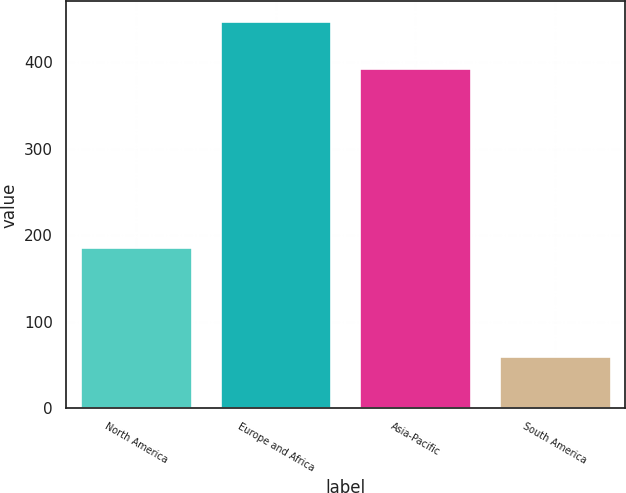Convert chart. <chart><loc_0><loc_0><loc_500><loc_500><bar_chart><fcel>North America<fcel>Europe and Africa<fcel>Asia-Pacific<fcel>South America<nl><fcel>186<fcel>448<fcel>394<fcel>61<nl></chart> 